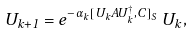Convert formula to latex. <formula><loc_0><loc_0><loc_500><loc_500>U _ { k + 1 } = e ^ { - \alpha _ { k } [ U _ { k } A U _ { k } ^ { \dagger } , C ] _ { S } } \, U _ { k } ,</formula> 